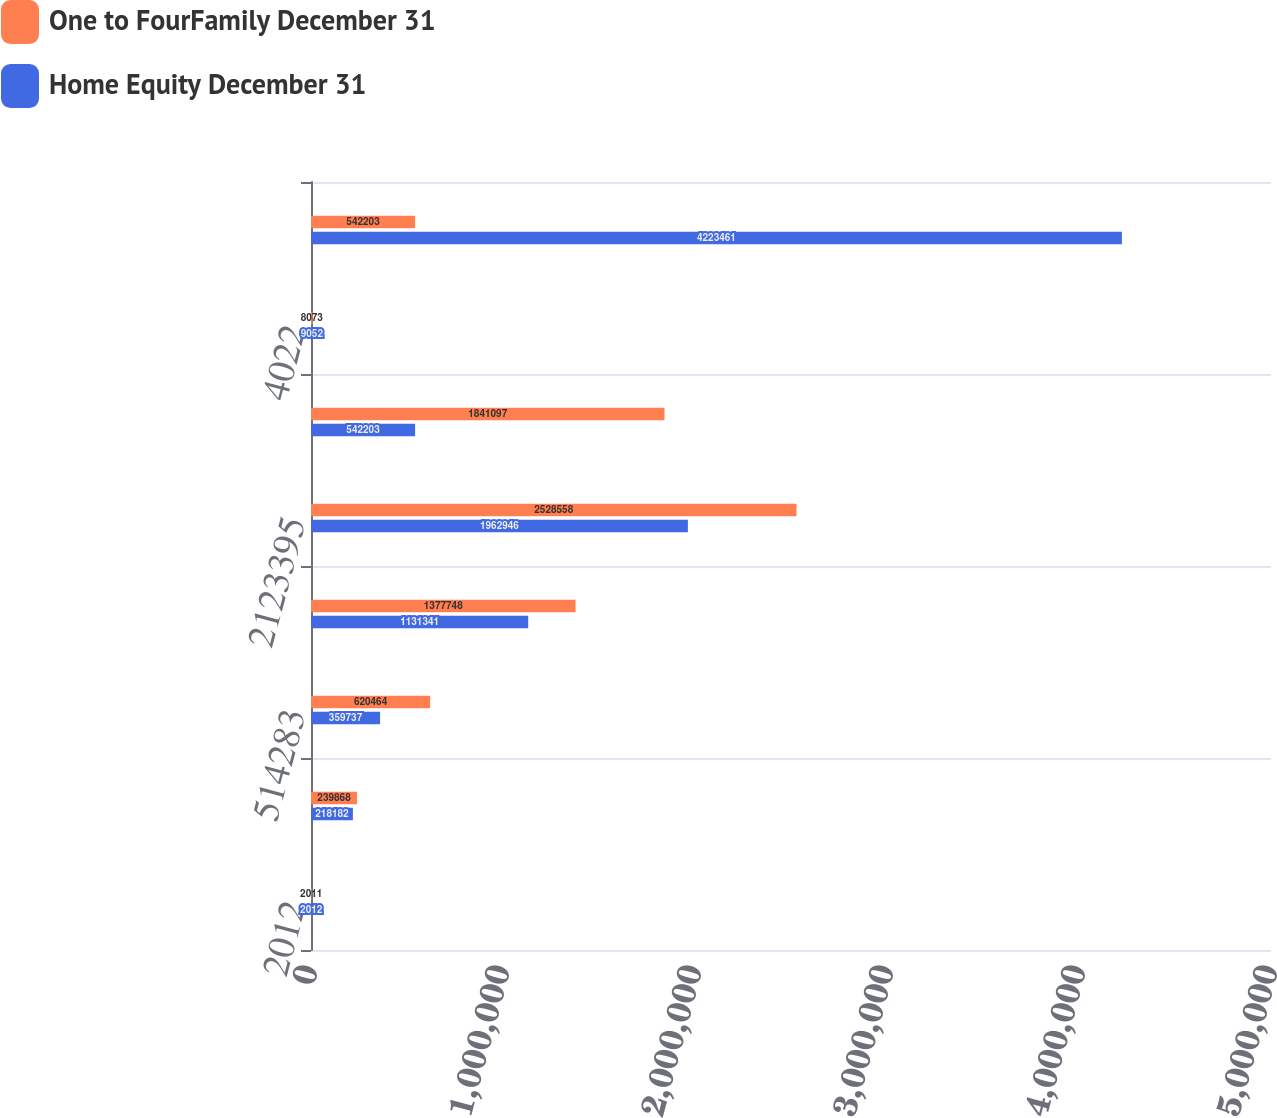<chart> <loc_0><loc_0><loc_500><loc_500><stacked_bar_chart><ecel><fcel>2012<fcel>190407<fcel>514283<fcel>1095047<fcel>2123395<fcel>1515020<fcel>4022<fcel>5442174<nl><fcel>One to FourFamily December 31<fcel>2011<fcel>239868<fcel>620464<fcel>1.37775e+06<fcel>2.52856e+06<fcel>1.8411e+06<fcel>8073<fcel>542203<nl><fcel>Home Equity December 31<fcel>2012<fcel>218182<fcel>359737<fcel>1.13134e+06<fcel>1.96295e+06<fcel>542203<fcel>9052<fcel>4.22346e+06<nl></chart> 